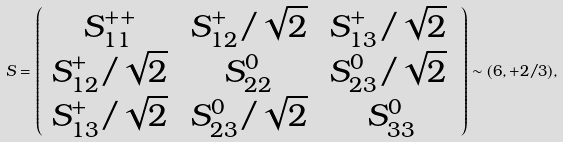<formula> <loc_0><loc_0><loc_500><loc_500>S = \left ( \begin{array} { c c c } { { S _ { 1 1 } ^ { + + } \, } } & { { S _ { 1 2 } ^ { + } / \sqrt { 2 } \, } } & { { S _ { 1 3 } ^ { + } / \sqrt { 2 } \, } } \\ { { S _ { 1 2 } ^ { + } / \sqrt { 2 } \, } } & { { S _ { 2 2 } ^ { 0 } \, } } & { { S _ { 2 3 } ^ { 0 } / \sqrt { 2 } \, } } \\ { { S _ { 1 3 } ^ { + } / \sqrt { 2 } \, } } & { { S _ { 2 3 } ^ { 0 } / \sqrt { 2 } \, } } & { { S _ { 3 3 } ^ { 0 } } } \end{array} \right ) \sim ( { 6 } , + 2 / 3 ) ,</formula> 